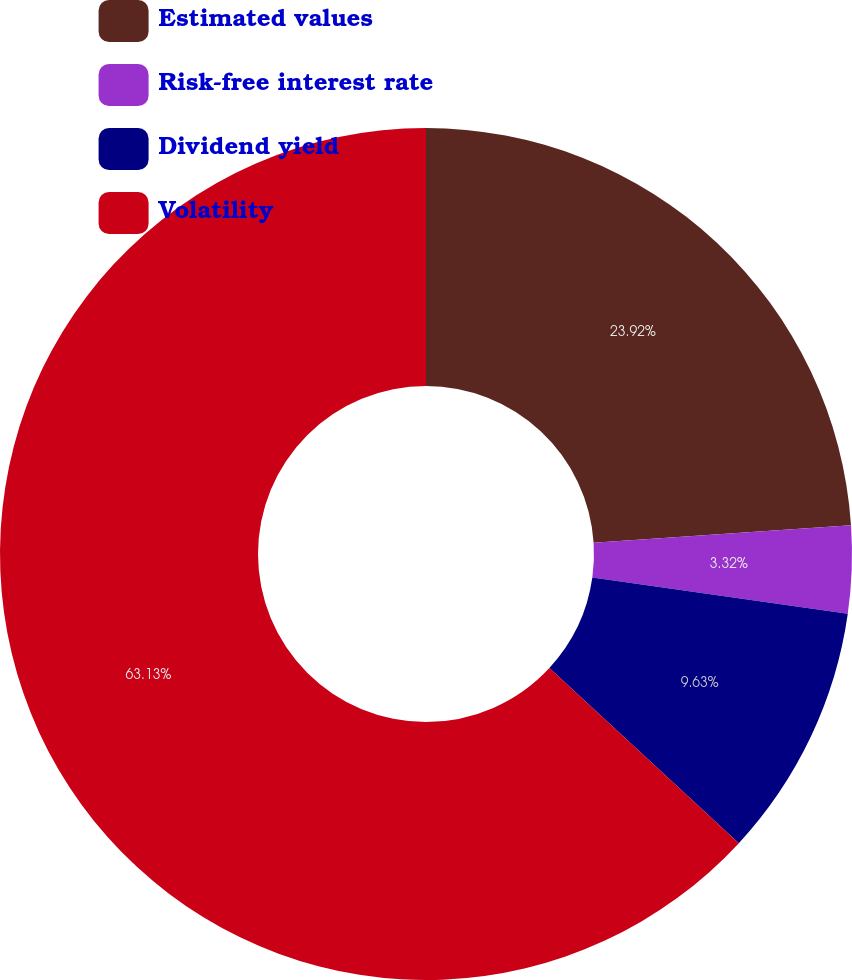<chart> <loc_0><loc_0><loc_500><loc_500><pie_chart><fcel>Estimated values<fcel>Risk-free interest rate<fcel>Dividend yield<fcel>Volatility<nl><fcel>23.92%<fcel>3.32%<fcel>9.63%<fcel>63.12%<nl></chart> 